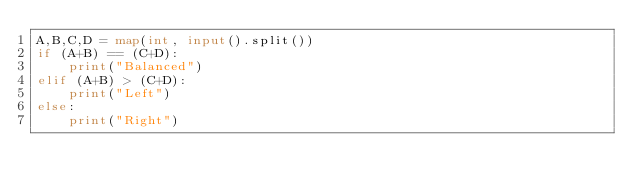<code> <loc_0><loc_0><loc_500><loc_500><_Python_>A,B,C,D = map(int, input().split())
if (A+B) == (C+D):
    print("Balanced")
elif (A+B) > (C+D):
    print("Left")
else:
    print("Right")</code> 